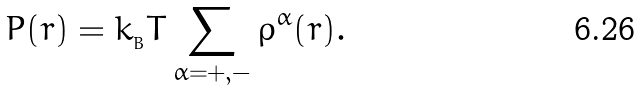<formula> <loc_0><loc_0><loc_500><loc_500>P ( { r } ) = k _ { _ { B } } T \sum _ { \alpha = + , - } \rho ^ { \alpha } ( { r } ) .</formula> 